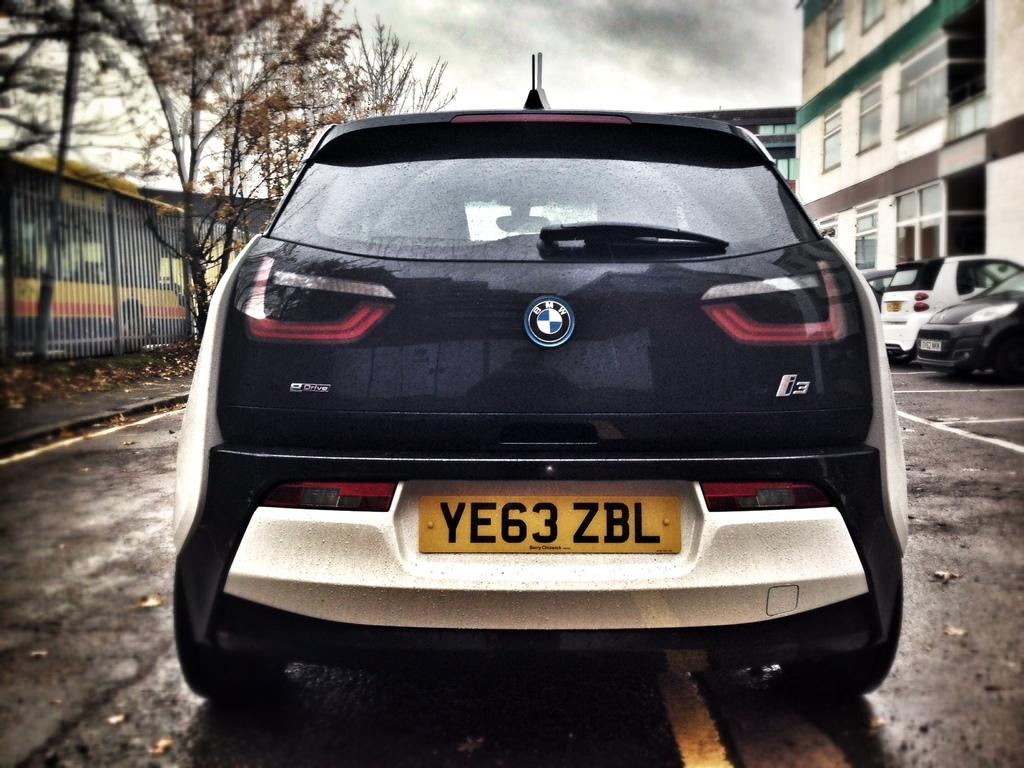What type of car is in the image? There is a BMW car in the image. Where is the car located? The car is on the road. What can be seen on the left side of the image? There are trees on the left side of the image. What is visible on the right side of the image? There are buildings on the right side of the image. What arithmetic problem can be solved using the car's license plate in the image? There is no license plate visible in the image, and therefore no arithmetic problem to solve. 